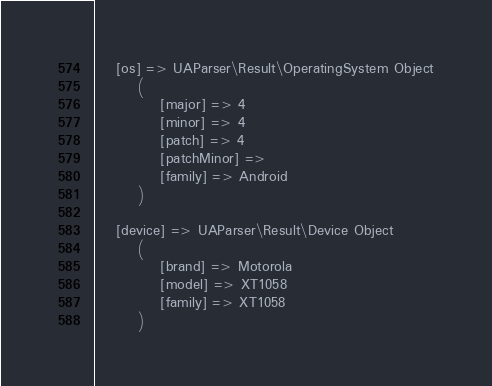Convert code to text. <code><loc_0><loc_0><loc_500><loc_500><_HTML_>    [os] => UAParser\Result\OperatingSystem Object
        (
            [major] => 4
            [minor] => 4
            [patch] => 4
            [patchMinor] => 
            [family] => Android
        )

    [device] => UAParser\Result\Device Object
        (
            [brand] => Motorola
            [model] => XT1058
            [family] => XT1058
        )
</code> 